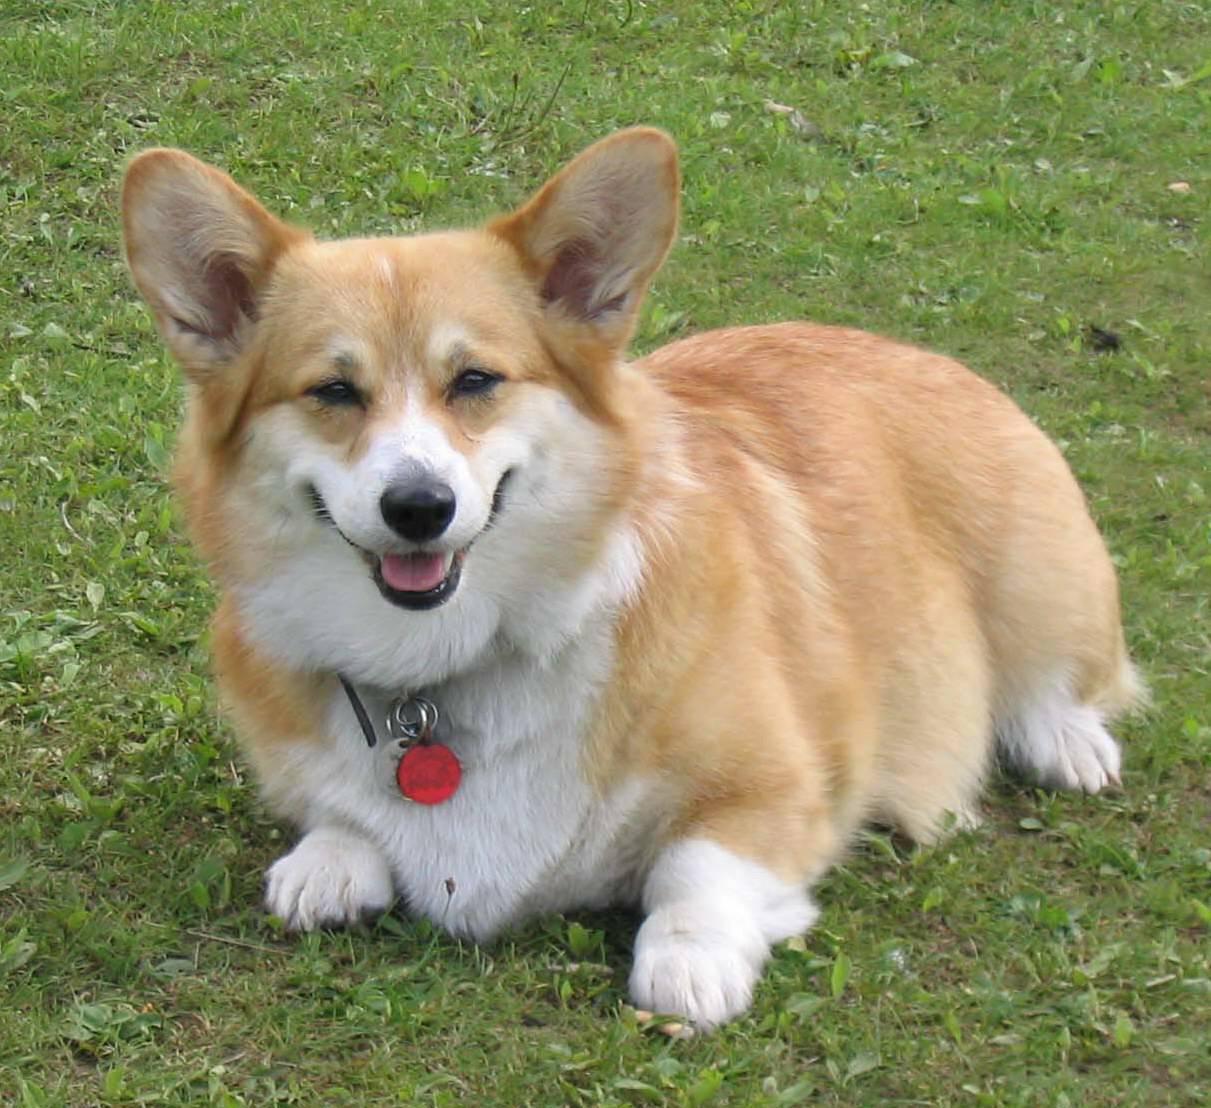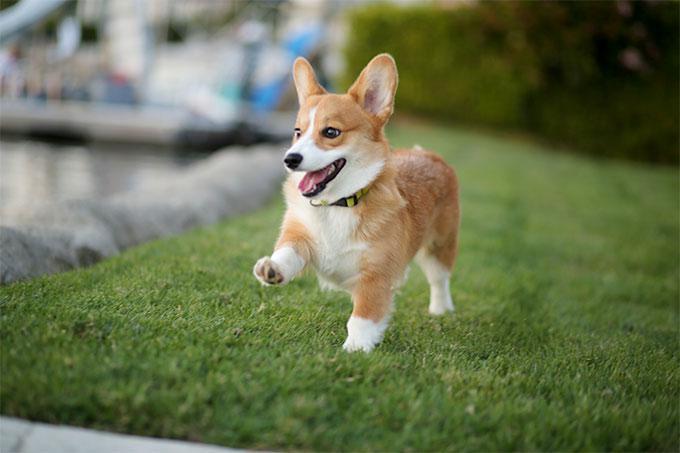The first image is the image on the left, the second image is the image on the right. Examine the images to the left and right. Is the description "In one image, the dog is not on green grass." accurate? Answer yes or no. No. 